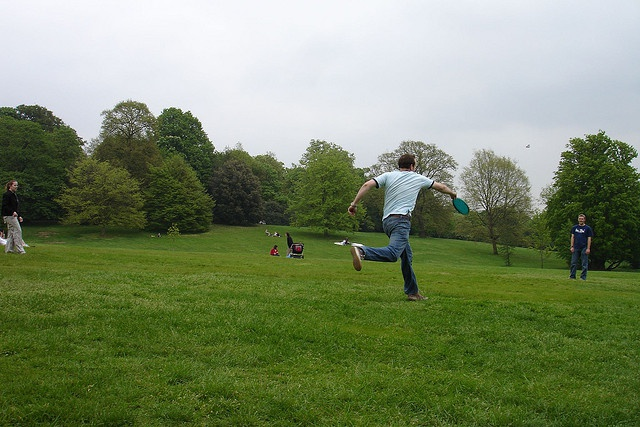Describe the objects in this image and their specific colors. I can see people in white, black, darkgreen, gray, and darkgray tones, people in white, black, gray, and darkgray tones, people in white, black, navy, and gray tones, frisbee in white, teal, black, darkgray, and gray tones, and people in white, darkgreen, black, and gray tones in this image. 